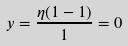Convert formula to latex. <formula><loc_0><loc_0><loc_500><loc_500>y = \frac { \eta ( 1 - 1 ) } { 1 } = 0</formula> 